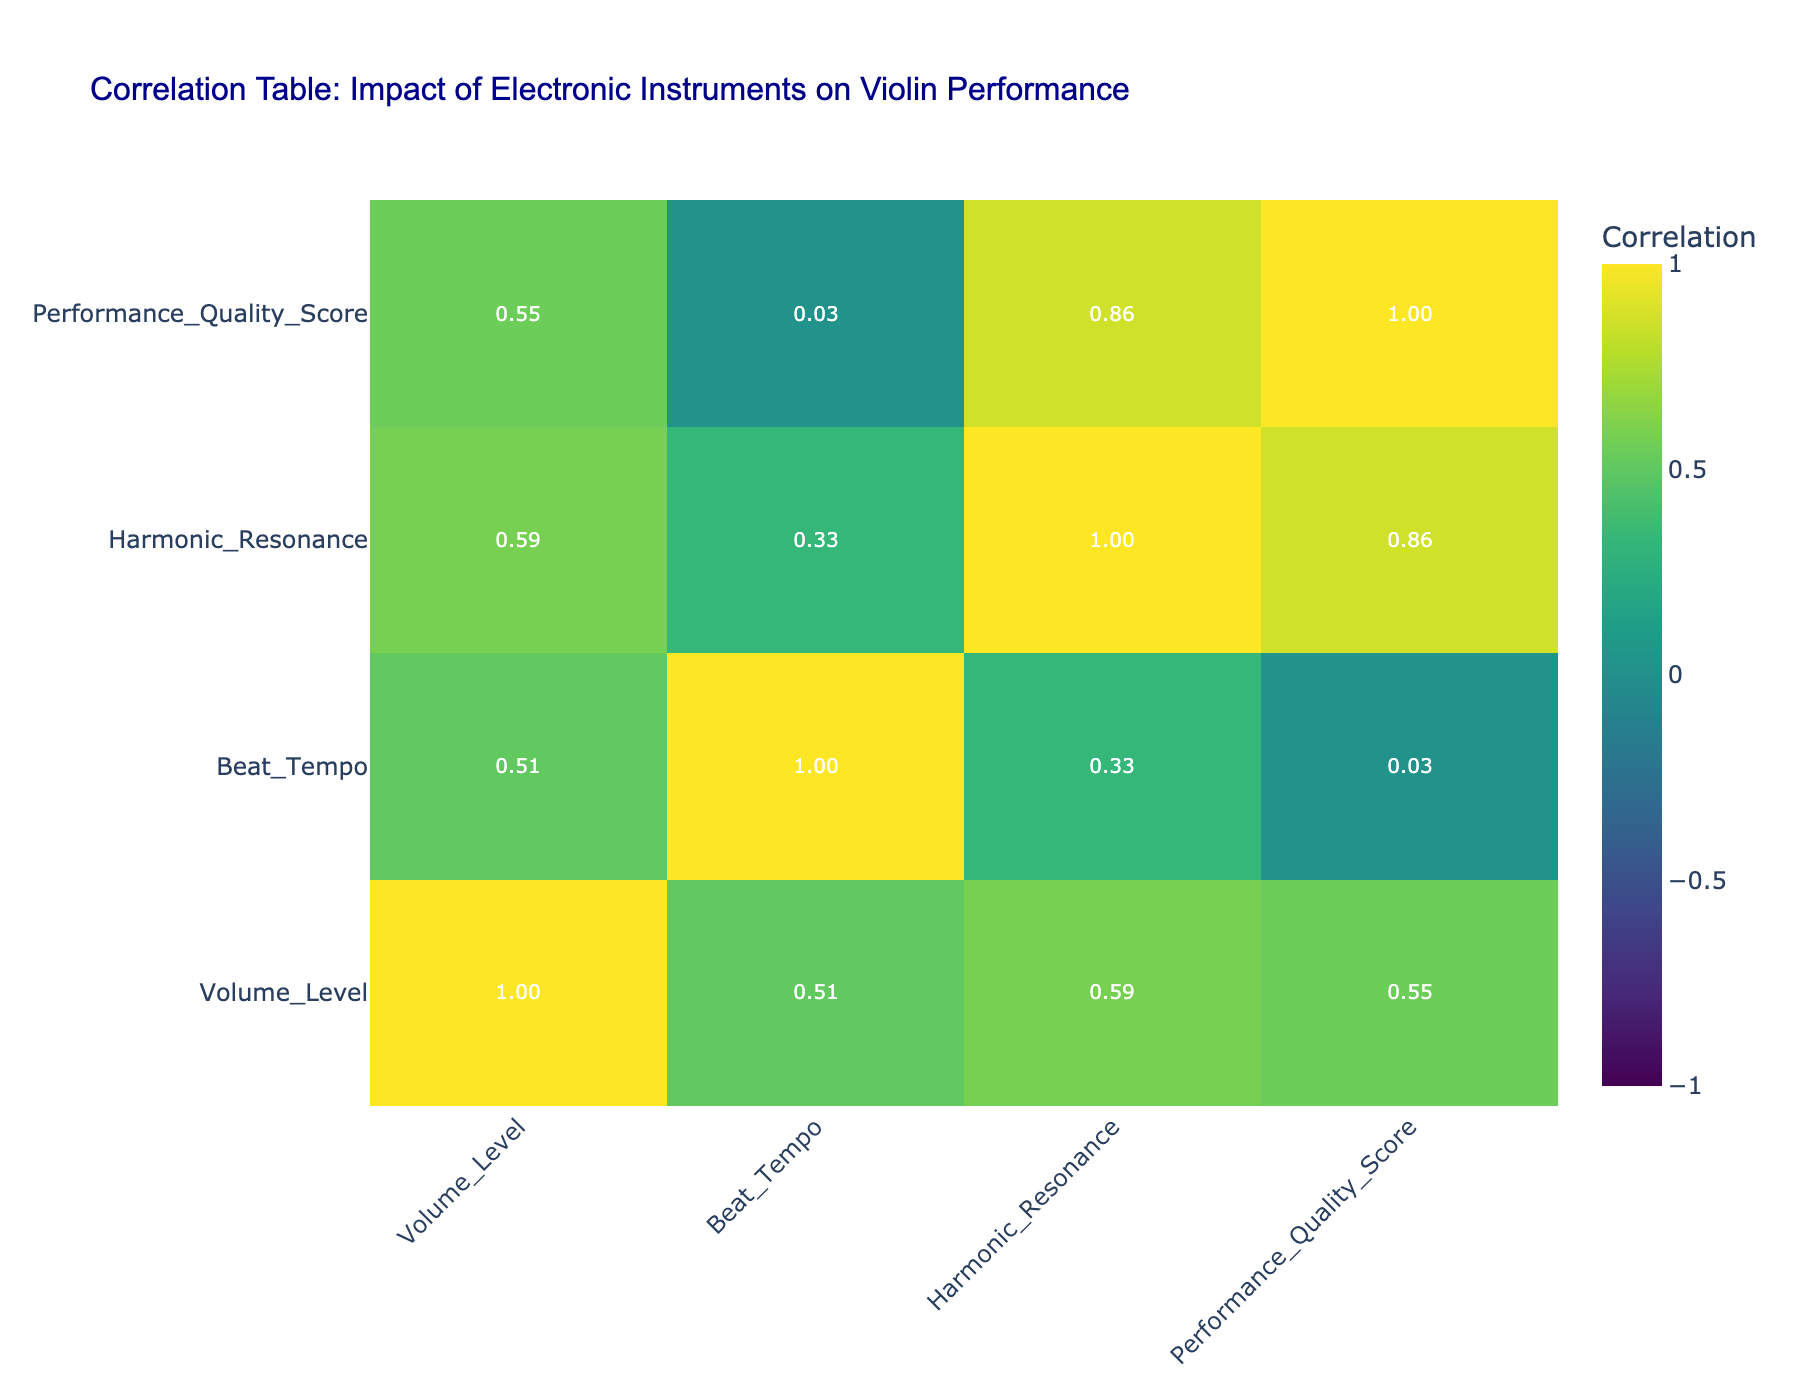What instrument shows the highest Performance Quality Score? From the table, we can directly see that the Loop Pedal, Sequencer, and Virtual Instruments all have a Performance Quality Score of 9. Among these, Virtual Instruments is listed last, but scores are equal. Thus, the instrument with the highest score is Virtual Instruments.
Answer: Virtual Instruments What is the correlation between Beat Tempo and Performance Quality Score? To answer this, we can refer to the correlation matrix section in the table where the correlation values are presented. By finding the intersecting value of Beat Tempo and Performance Quality Score, we determine that the correlation is significant.
Answer: The correlation is high Which electronic instrument has the lowest Volume Level? According to the data, the Bass Synth has the lowest Volume Level of 60. This is confirmed by checking the Volume Level values of all electronic instruments listed.
Answer: Bass Synth What is the average Volume Level of the instruments that scored above 8 in Performance Quality? The instruments that have a Performance Quality Score above 8 are the Loop Pedal, Sequencer, and Virtual Instruments. Their Volume Levels are 70, 90, and 85 respectively. The sum of these Volume Levels is 70 + 90 + 85 = 245. Since there are three instruments, the average is calculated by dividing the total by 3: 245 / 3 = 81.67.
Answer: 81.67 Is there a negative correlation between Harmonic Resonance and Performance Quality Score? We need to look at the correlation value between Harmonic Resonance and Performance Quality Score from the table. The correlation value is positive above 0.65, indicating that there is no negative correlation. The statement is false.
Answer: No, the correlation is positive 